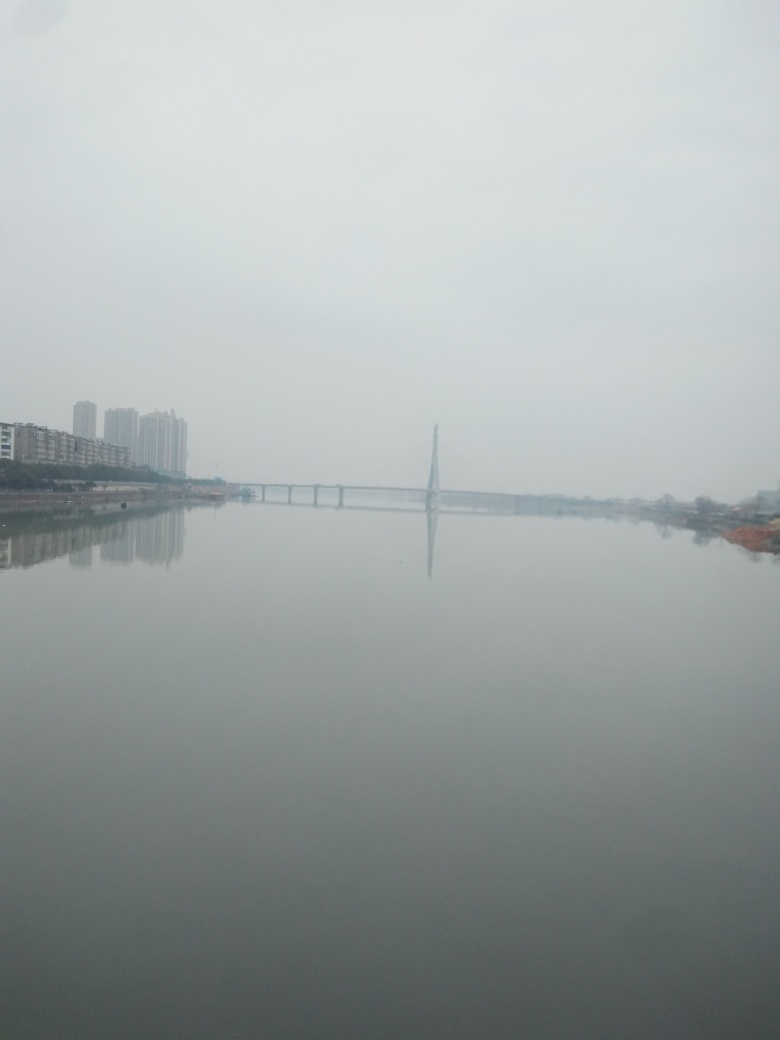Are there any quality issues with this image? Yes, the image appears to be hazy which may be due to atmospheric conditions like fog or pollution, or it could be a result of low resolution or incorrect camera settings. Additionally, the composition could be improved for better aesthetic appeal as the subject is centered with excess space at the top. 